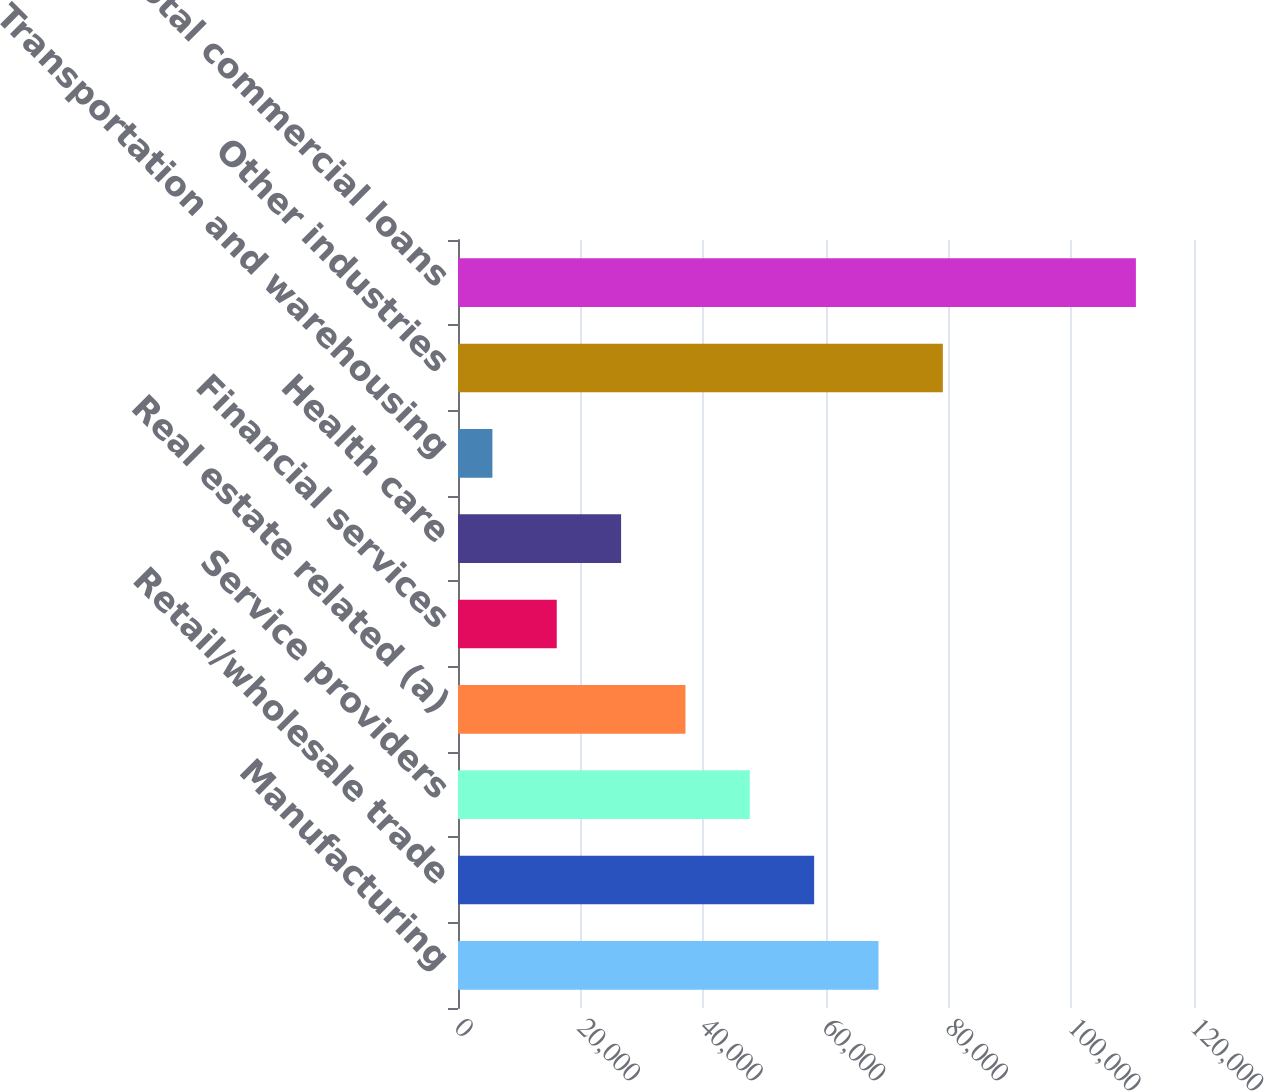Convert chart. <chart><loc_0><loc_0><loc_500><loc_500><bar_chart><fcel>Manufacturing<fcel>Retail/wholesale trade<fcel>Service providers<fcel>Real estate related (a)<fcel>Financial services<fcel>Health care<fcel>Transportation and warehousing<fcel>Other industries<fcel>Total commercial loans<nl><fcel>68559.8<fcel>58068<fcel>47576.2<fcel>37084.4<fcel>16100.8<fcel>26592.6<fcel>5609<fcel>79051.6<fcel>110527<nl></chart> 